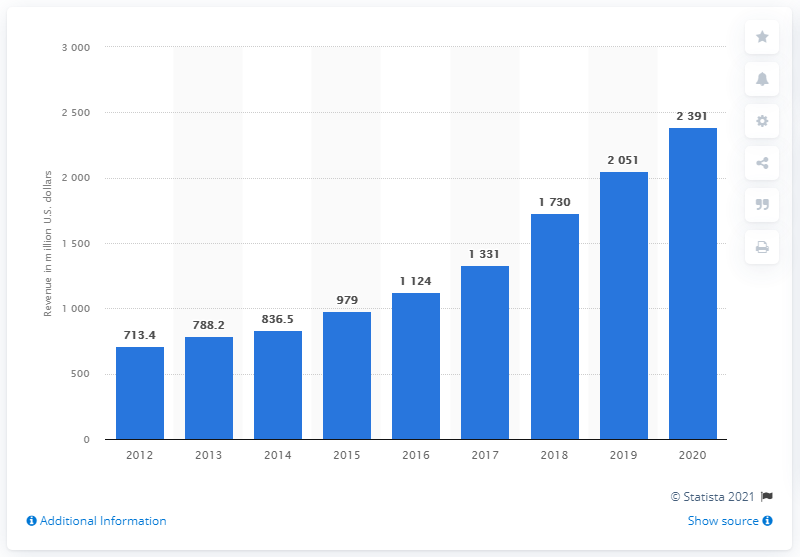Specify some key components in this picture. The Match Group's dating revenue in the last reported year was 2,391. 